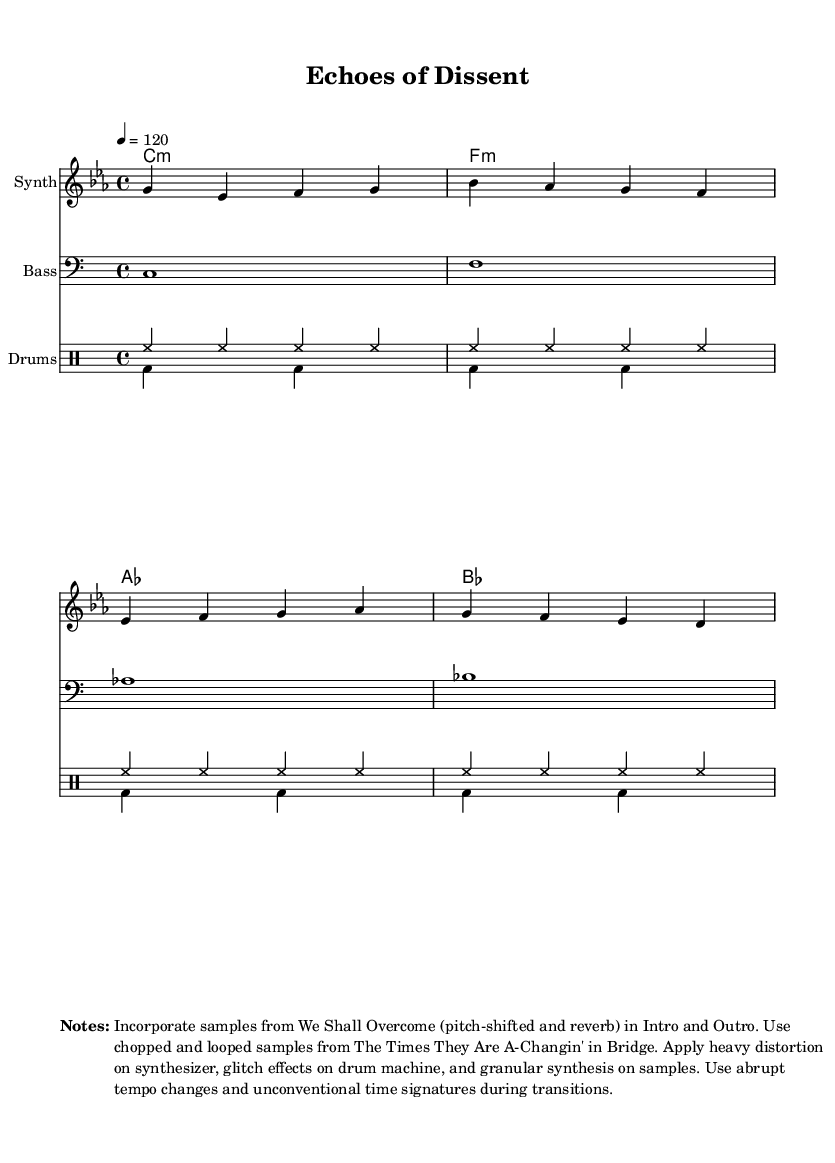What is the key signature of this music? The key signature is C minor, which includes three flats (B♭, E♭, A♭). This is indicated at the beginning of the score where the key signature is displayed.
Answer: C minor What is the time signature of this music? The time signature is 4/4, which is indicated at the beginning of the score. This means there are four beats in each measure and the quarter note receives one beat.
Answer: 4/4 What is the tempo marking for this composition? The tempo marking is indicated as 4 = 120, meaning that there are 120 beats per minute, with each beat corresponding to a quarter note.
Answer: 120 How many measures are there in the melody section? By counting the measures in the melody line, there are a total of 4 measures present. Each group of notes separated by vertical lines represents one measure.
Answer: 4 What type of synthesis effect is applied to the synthesizer? The synthesizer has heavy distortion applied to it, which is a specific effect used to alter the sound by clipping the audio signal. This is noted in the markup section of the score.
Answer: Heavy distortion What samples are used during the Intro and Outro sections? The samples used are from "We Shall Overcome," which are pitch-shifted and reverb processed. This information is specified in the notes section of the score.
Answer: We Shall Overcome Which protest song is sampled in the bridge section? The song sampled in the bridge section is "The Times They Are A-Changin'," which is described as being chopped and looped. This detail is provided in the markup section.
Answer: The Times They Are A-Changin' 